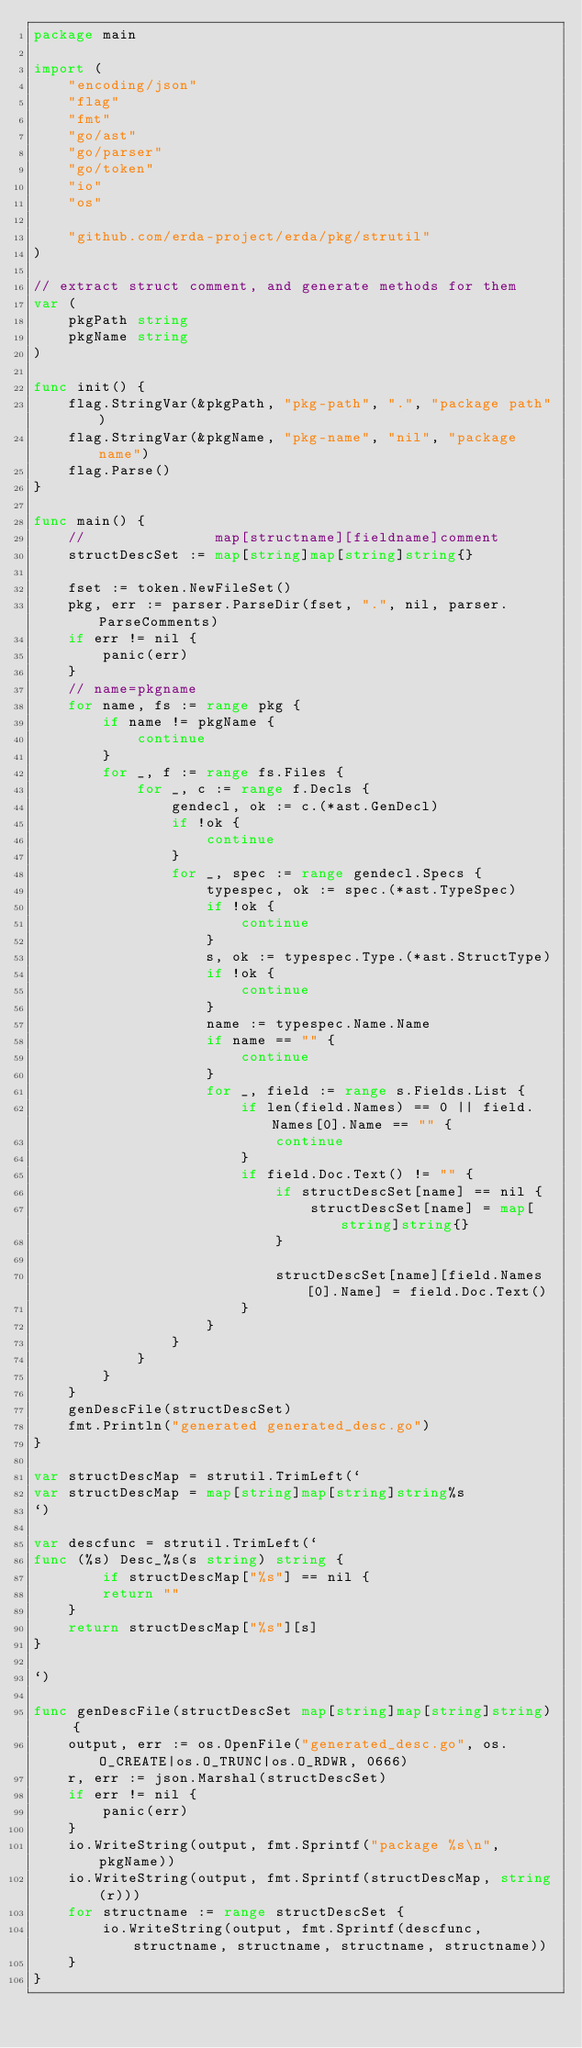Convert code to text. <code><loc_0><loc_0><loc_500><loc_500><_Go_>package main

import (
	"encoding/json"
	"flag"
	"fmt"
	"go/ast"
	"go/parser"
	"go/token"
	"io"
	"os"

	"github.com/erda-project/erda/pkg/strutil"
)

// extract struct comment, and generate methods for them
var (
	pkgPath string
	pkgName string
)

func init() {
	flag.StringVar(&pkgPath, "pkg-path", ".", "package path")
	flag.StringVar(&pkgName, "pkg-name", "nil", "package name")
	flag.Parse()
}

func main() {
	//               map[structname][fieldname]comment
	structDescSet := map[string]map[string]string{}

	fset := token.NewFileSet()
	pkg, err := parser.ParseDir(fset, ".", nil, parser.ParseComments)
	if err != nil {
		panic(err)
	}
	// name=pkgname
	for name, fs := range pkg {
		if name != pkgName {
			continue
		}
		for _, f := range fs.Files {
			for _, c := range f.Decls {
				gendecl, ok := c.(*ast.GenDecl)
				if !ok {
					continue
				}
				for _, spec := range gendecl.Specs {
					typespec, ok := spec.(*ast.TypeSpec)
					if !ok {
						continue
					}
					s, ok := typespec.Type.(*ast.StructType)
					if !ok {
						continue
					}
					name := typespec.Name.Name
					if name == "" {
						continue
					}
					for _, field := range s.Fields.List {
						if len(field.Names) == 0 || field.Names[0].Name == "" {
							continue
						}
						if field.Doc.Text() != "" {
							if structDescSet[name] == nil {
								structDescSet[name] = map[string]string{}
							}

							structDescSet[name][field.Names[0].Name] = field.Doc.Text()
						}
					}
				}
			}
		}
	}
	genDescFile(structDescSet)
	fmt.Println("generated generated_desc.go")
}

var structDescMap = strutil.TrimLeft(`
var structDescMap = map[string]map[string]string%s
`)

var descfunc = strutil.TrimLeft(`
func (%s) Desc_%s(s string) string {
        if structDescMap["%s"] == nil {
		return ""
	}
	return structDescMap["%s"][s]
}

`)

func genDescFile(structDescSet map[string]map[string]string) {
	output, err := os.OpenFile("generated_desc.go", os.O_CREATE|os.O_TRUNC|os.O_RDWR, 0666)
	r, err := json.Marshal(structDescSet)
	if err != nil {
		panic(err)
	}
	io.WriteString(output, fmt.Sprintf("package %s\n", pkgName))
	io.WriteString(output, fmt.Sprintf(structDescMap, string(r)))
	for structname := range structDescSet {
		io.WriteString(output, fmt.Sprintf(descfunc, structname, structname, structname, structname))
	}
}
</code> 